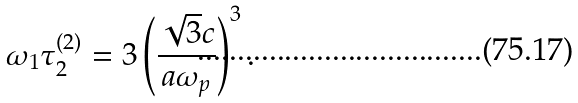<formula> <loc_0><loc_0><loc_500><loc_500>\omega _ { 1 } \tau ^ { ( 2 ) } _ { 2 } = 3 \left ( \frac { \sqrt { 3 } c } { a \omega _ { p } } \right ) ^ { 3 } .</formula> 